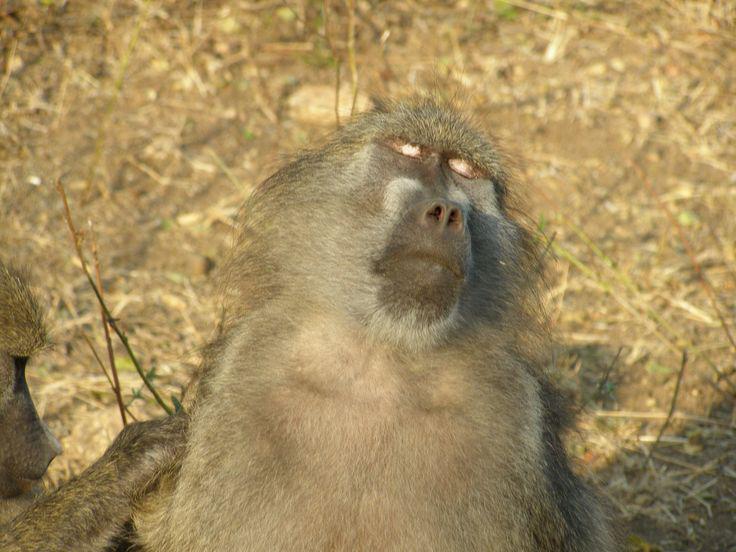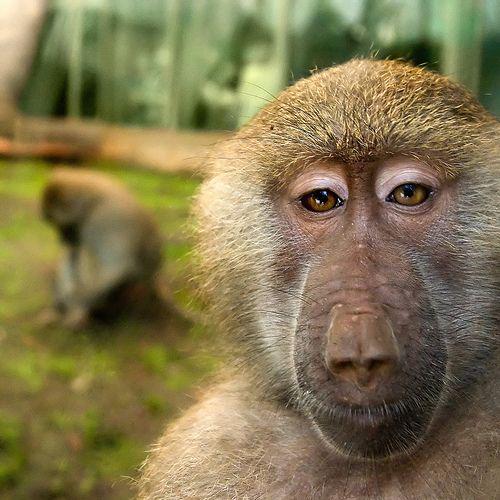The first image is the image on the left, the second image is the image on the right. Examine the images to the left and right. Is the description "The monkey in the left hand image has creepy red eyes." accurate? Answer yes or no. No. 